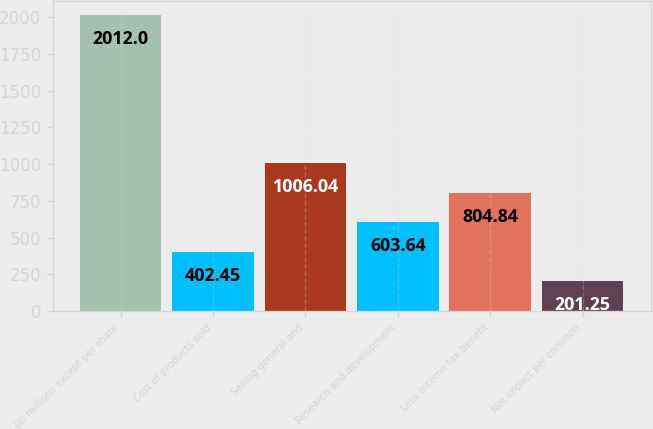Convert chart. <chart><loc_0><loc_0><loc_500><loc_500><bar_chart><fcel>(in millions except per share<fcel>Cost of products sold<fcel>Selling general and<fcel>Research and development<fcel>Less income tax benefit<fcel>Net impact per common<nl><fcel>2012<fcel>402.45<fcel>1006.04<fcel>603.64<fcel>804.84<fcel>201.25<nl></chart> 